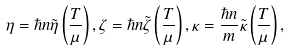Convert formula to latex. <formula><loc_0><loc_0><loc_500><loc_500>\eta = \hbar { n } \tilde { \eta } \left ( \frac { T } { \mu } \right ) , \zeta = \hbar { n } \tilde { \zeta } \left ( \frac { T } { \mu } \right ) , \kappa = \frac { \hbar { n } } m \tilde { \kappa } \left ( \frac { T } { \mu } \right ) ,</formula> 